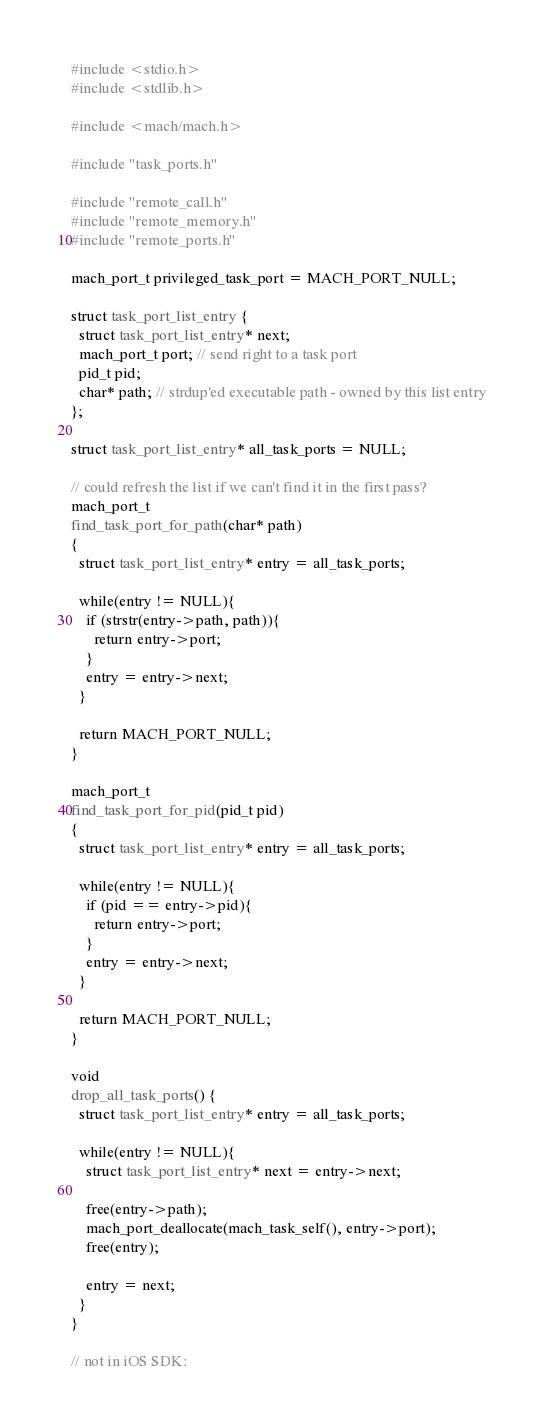Convert code to text. <code><loc_0><loc_0><loc_500><loc_500><_C_>#include <stdio.h>
#include <stdlib.h>

#include <mach/mach.h>

#include "task_ports.h"

#include "remote_call.h"
#include "remote_memory.h"
#include "remote_ports.h"

mach_port_t privileged_task_port = MACH_PORT_NULL;

struct task_port_list_entry {
  struct task_port_list_entry* next;
  mach_port_t port; // send right to a task port
  pid_t pid;
  char* path; // strdup'ed executable path - owned by this list entry
};

struct task_port_list_entry* all_task_ports = NULL;

// could refresh the list if we can't find it in the first pass?
mach_port_t
find_task_port_for_path(char* path)
{
  struct task_port_list_entry* entry = all_task_ports;
  
  while(entry != NULL){
    if (strstr(entry->path, path)){
      return entry->port;
    }
    entry = entry->next;
  }
  
  return MACH_PORT_NULL;
}

mach_port_t
find_task_port_for_pid(pid_t pid)
{
  struct task_port_list_entry* entry = all_task_ports;
  
  while(entry != NULL){
    if (pid == entry->pid){
      return entry->port;
    }
    entry = entry->next;
  }
  
  return MACH_PORT_NULL;
}

void
drop_all_task_ports() {
  struct task_port_list_entry* entry = all_task_ports;
  
  while(entry != NULL){
    struct task_port_list_entry* next = entry->next;
    
    free(entry->path);
    mach_port_deallocate(mach_task_self(), entry->port);
    free(entry);
    
    entry = next;
  }
}

// not in iOS SDK:</code> 